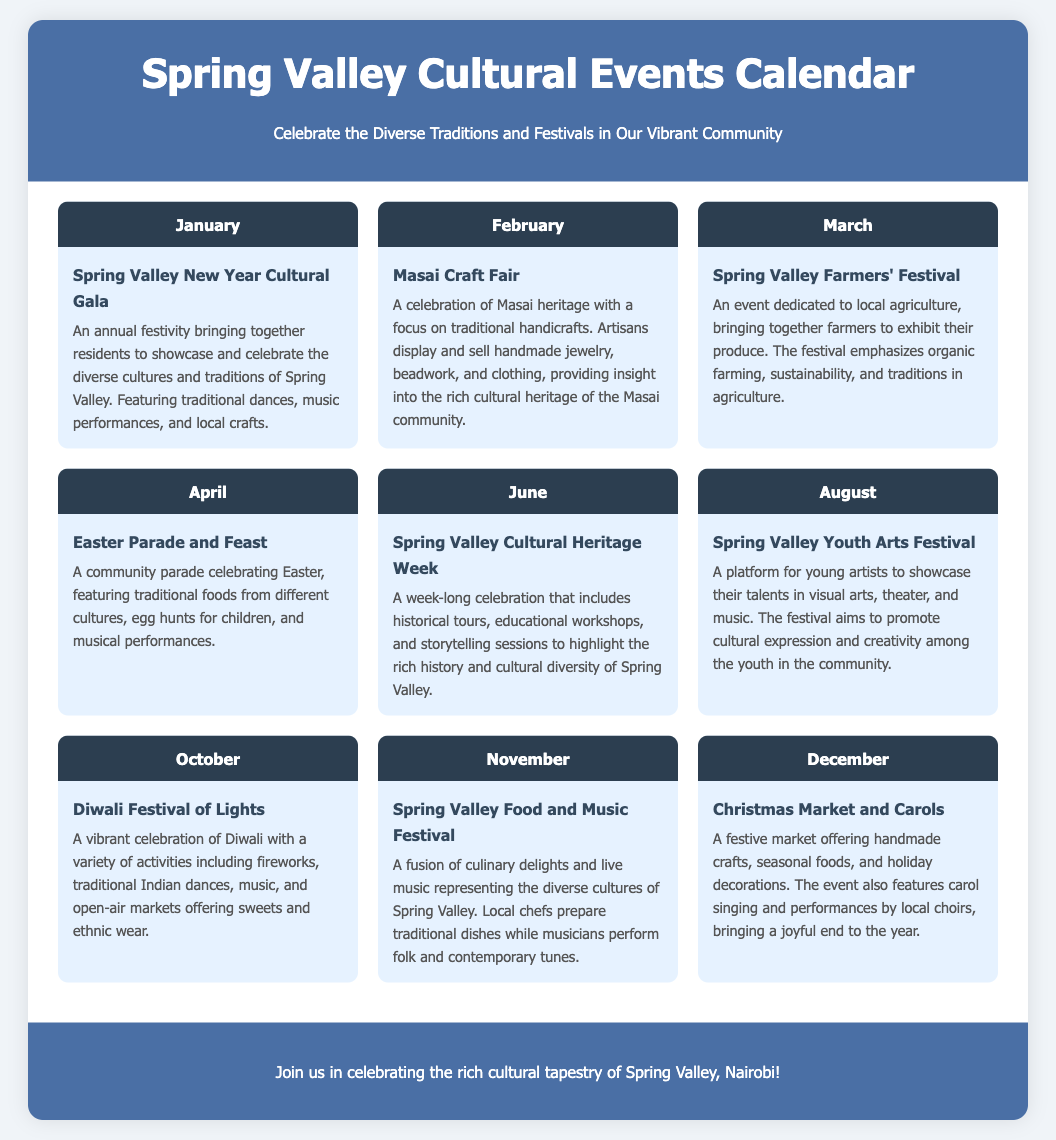What is the title of the January event? The title of the January event is the Spring Valley New Year Cultural Gala, which is listed in the January month section.
Answer: Spring Valley New Year Cultural Gala How many events take place in June? The document specifies that there is one event listed for June, which is the Spring Valley Cultural Heritage Week.
Answer: 1 What is the main focus of the Masai Craft Fair? The document states that the Masai Craft Fair focuses on traditional handicrafts and provides insight into the rich cultural heritage of the Masai community.
Answer: Traditional handicrafts Which month features the Diwali Festival of Lights? The document explicitly mentions that the Diwali Festival of Lights occurs in October.
Answer: October What type of performances are included in the Easter Parade and Feast? The Easter Parade and Feast includes musical performances as mentioned in the description of the event for April.
Answer: Musical performances How does the Spring Valley Youth Arts Festival promote creativity? The document indicates that the Spring Valley Youth Arts Festival provides a platform for young artists to showcase their talents in various art forms.
Answer: Showcasing talents What is celebrated during the Spring Valley Food and Music Festival? The document describes the Spring Valley Food and Music Festival as a fusion of culinary delights and live music that represents diverse cultures.
Answer: Culinary delights and live music When does the Christmas Market and Carols take place? According to the document, the Christmas Market and Carols is held in December.
Answer: December 